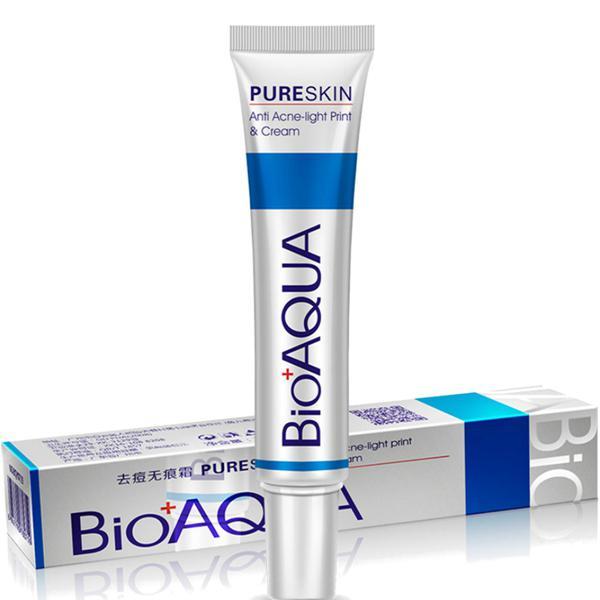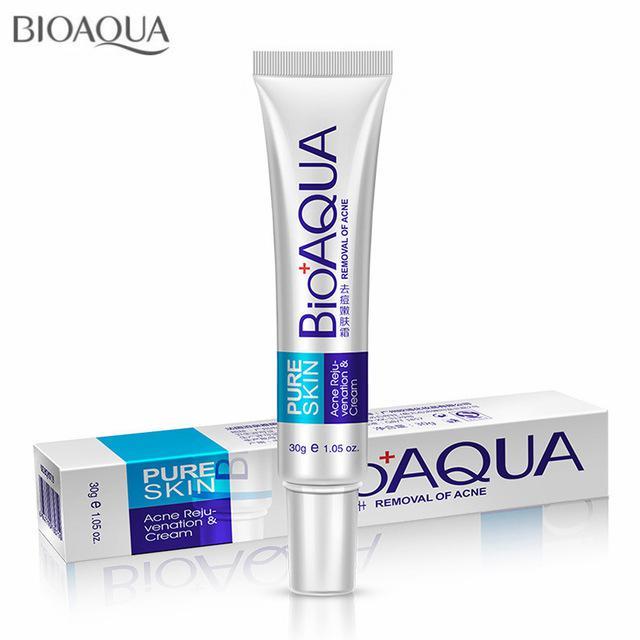The first image is the image on the left, the second image is the image on the right. Examine the images to the left and right. Is the description "The left and right image contains the same number of  boxes and face cream bottles." accurate? Answer yes or no. Yes. The first image is the image on the left, the second image is the image on the right. Evaluate the accuracy of this statement regarding the images: "The right image shows a tube product standing on its cap to the right of its upright box.". Is it true? Answer yes or no. No. 